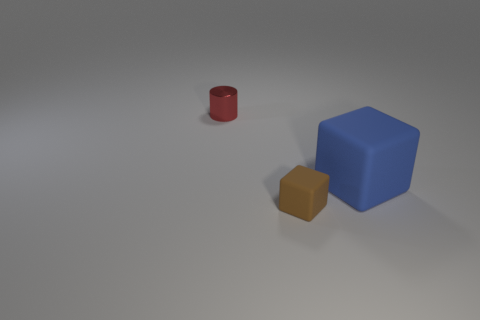Is the number of brown matte cubes that are to the left of the tiny brown rubber thing less than the number of blue metallic objects?
Ensure brevity in your answer.  No. There is a rubber thing in front of the rubber thing that is to the right of the cube on the left side of the large rubber block; what shape is it?
Give a very brief answer. Cube. Do the big rubber thing and the metal thing have the same color?
Give a very brief answer. No. Is the number of yellow matte objects greater than the number of big blue objects?
Make the answer very short. No. What number of other objects are the same material as the small block?
Ensure brevity in your answer.  1. What number of things are small shiny objects or blocks on the left side of the big blue matte thing?
Your answer should be compact. 2. Are there fewer purple cubes than brown rubber things?
Keep it short and to the point. Yes. There is a small thing that is in front of the small object that is behind the tiny thing that is on the right side of the small metallic thing; what is its color?
Offer a very short reply. Brown. Are the tiny red cylinder and the large block made of the same material?
Make the answer very short. No. There is a blue rubber cube; what number of red shiny cylinders are to the left of it?
Make the answer very short. 1. 